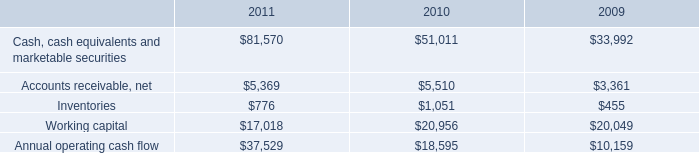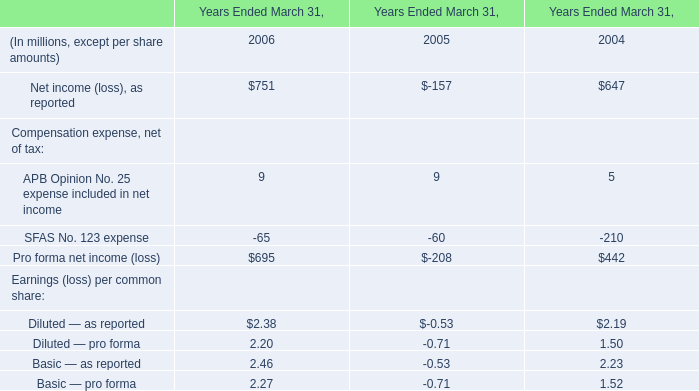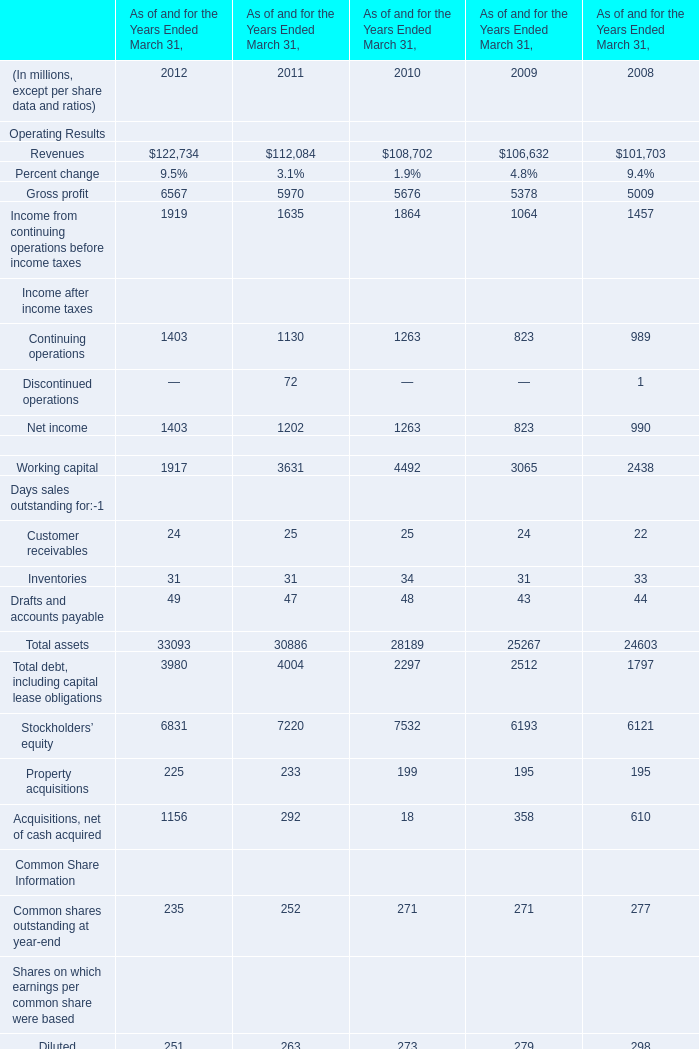What is the sum of Customer receivables, Inventories and Drafts and accounts payable in 2012 ? (in million) 
Computations: ((24 + 31) + 49)
Answer: 104.0. 